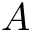<formula> <loc_0><loc_0><loc_500><loc_500>A</formula> 